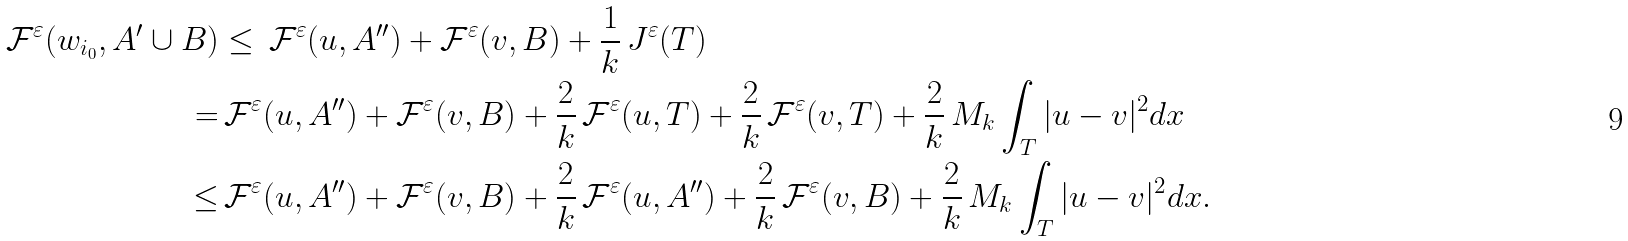<formula> <loc_0><loc_0><loc_500><loc_500>\mathcal { F } ^ { \varepsilon } ( w _ { i _ { 0 } } , A ^ { \prime } \cup B ) & \leq \, \mathcal { F } ^ { \varepsilon } ( u , A ^ { \prime \prime } ) + \mathcal { F } ^ { \varepsilon } ( v , B ) + \frac { 1 } { k } \, J ^ { \varepsilon } ( T ) \\ = & \, \mathcal { F } ^ { \varepsilon } ( u , A ^ { \prime \prime } ) + \mathcal { F } ^ { \varepsilon } ( v , B ) + \frac { 2 } { k } \, \mathcal { F } ^ { \varepsilon } ( u , T ) + \frac { 2 } { k } \, \mathcal { F } ^ { \varepsilon } ( v , T ) + \frac { 2 } { k } \, M _ { k } \int _ { T } | u - v | ^ { 2 } d x \\ \leq & \, \mathcal { F } ^ { \varepsilon } ( u , A ^ { \prime \prime } ) + \mathcal { F } ^ { \varepsilon } ( v , B ) + \frac { 2 } { k } \, \mathcal { F } ^ { \varepsilon } ( u , A ^ { \prime \prime } ) + \frac { 2 } { k } \, \mathcal { F } ^ { \varepsilon } ( v , B ) + \frac { 2 } { k } \, M _ { k } \int _ { T } | u - v | ^ { 2 } d x .</formula> 